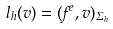<formula> <loc_0><loc_0><loc_500><loc_500>l _ { h } ( v ) = ( f ^ { e } , v ) _ { \Sigma _ { h } }</formula> 